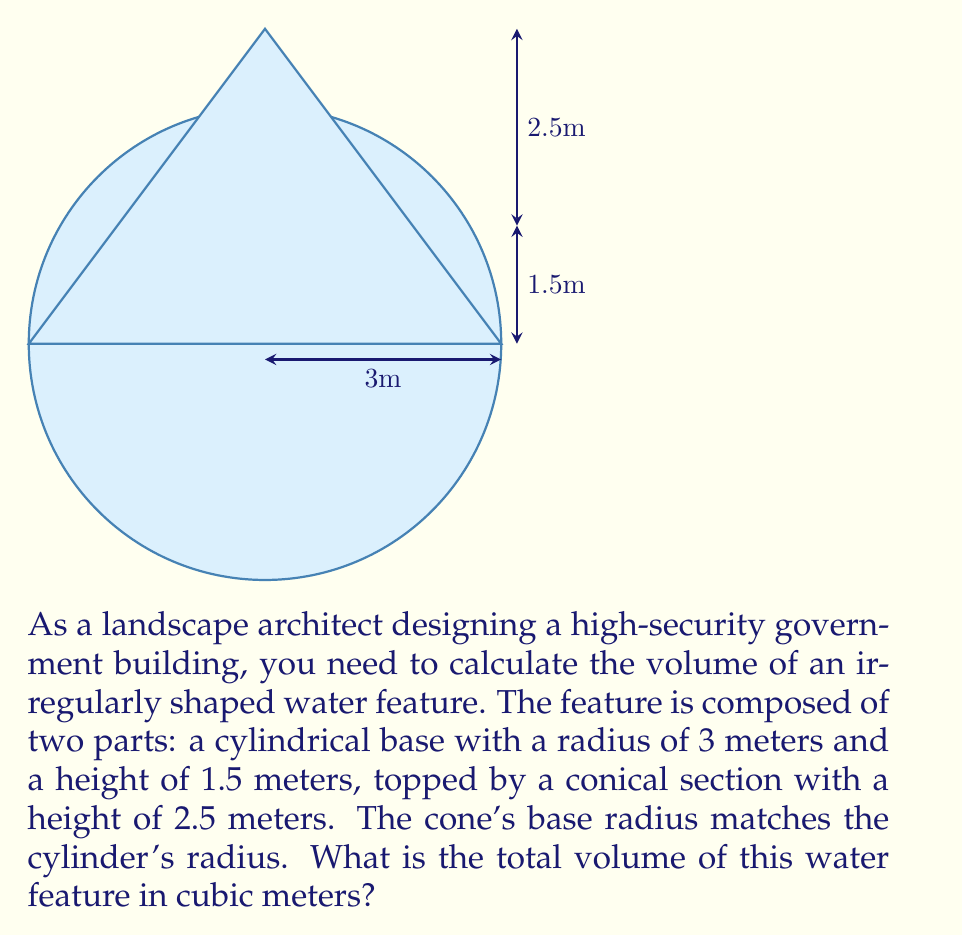Solve this math problem. To solve this problem, we need to calculate the volumes of both the cylindrical and conical parts separately, then add them together.

1. Volume of the cylindrical base:
   The formula for the volume of a cylinder is $V_c = \pi r^2 h$
   Where $r$ is the radius and $h$ is the height.
   
   $V_c = \pi (3\text{ m})^2 (1.5\text{ m})$
   $V_c = \pi (9\text{ m}^2) (1.5\text{ m})$
   $V_c = 13.5\pi\text{ m}^3$

2. Volume of the conical top:
   The formula for the volume of a cone is $V_n = \frac{1}{3}\pi r^2 h$
   Where $r$ is the radius of the base and $h$ is the height.
   
   $V_n = \frac{1}{3}\pi (3\text{ m})^2 (2.5\text{ m})$
   $V_n = \frac{1}{3}\pi (9\text{ m}^2) (2.5\text{ m})$
   $V_n = 7.5\pi\text{ m}^3$

3. Total volume:
   $V_{\text{total}} = V_c + V_n$
   $V_{\text{total}} = 13.5\pi\text{ m}^3 + 7.5\pi\text{ m}^3$
   $V_{\text{total}} = 21\pi\text{ m}^3$

4. Simplifying:
   $V_{\text{total}} = 21\pi\text{ m}^3 \approx 65.97\text{ m}^3$
Answer: $65.97\text{ m}^3$ 